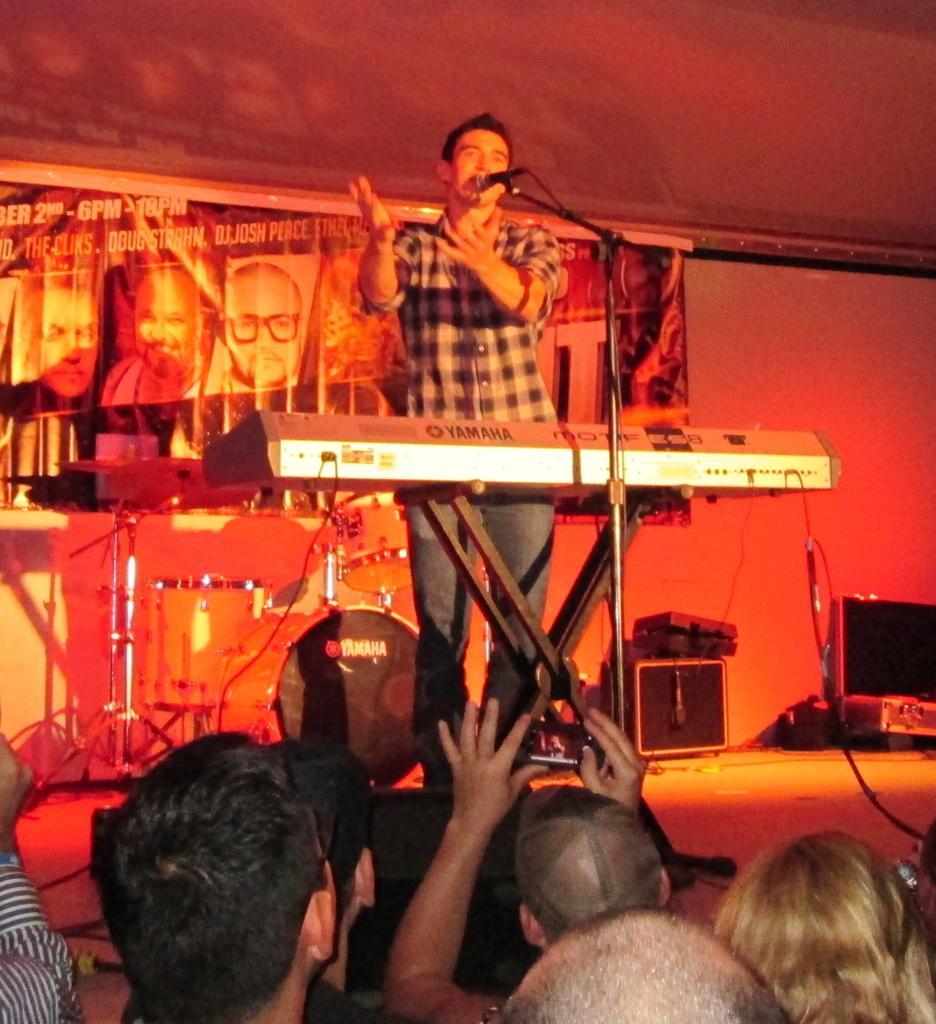Can you describe this image briefly? In this image I can see at the bottom it looks like a person is trying to capture the image with a mobile phone, beside him few people are there. In the middle a man is standing and singing in the microphone, he is wearing a shirt, trouser. At the back side there is a banner. 